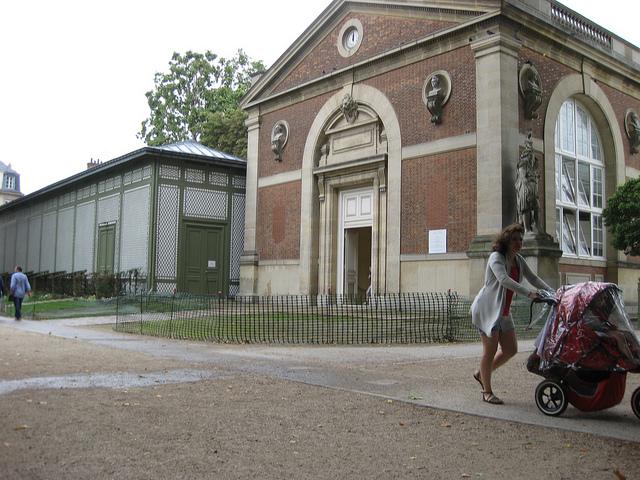What is the building built out of?
Answer briefly. Bricks. Is the baby in a bubble?
Give a very brief answer. No. Is the building a church?
Write a very short answer. Yes. 